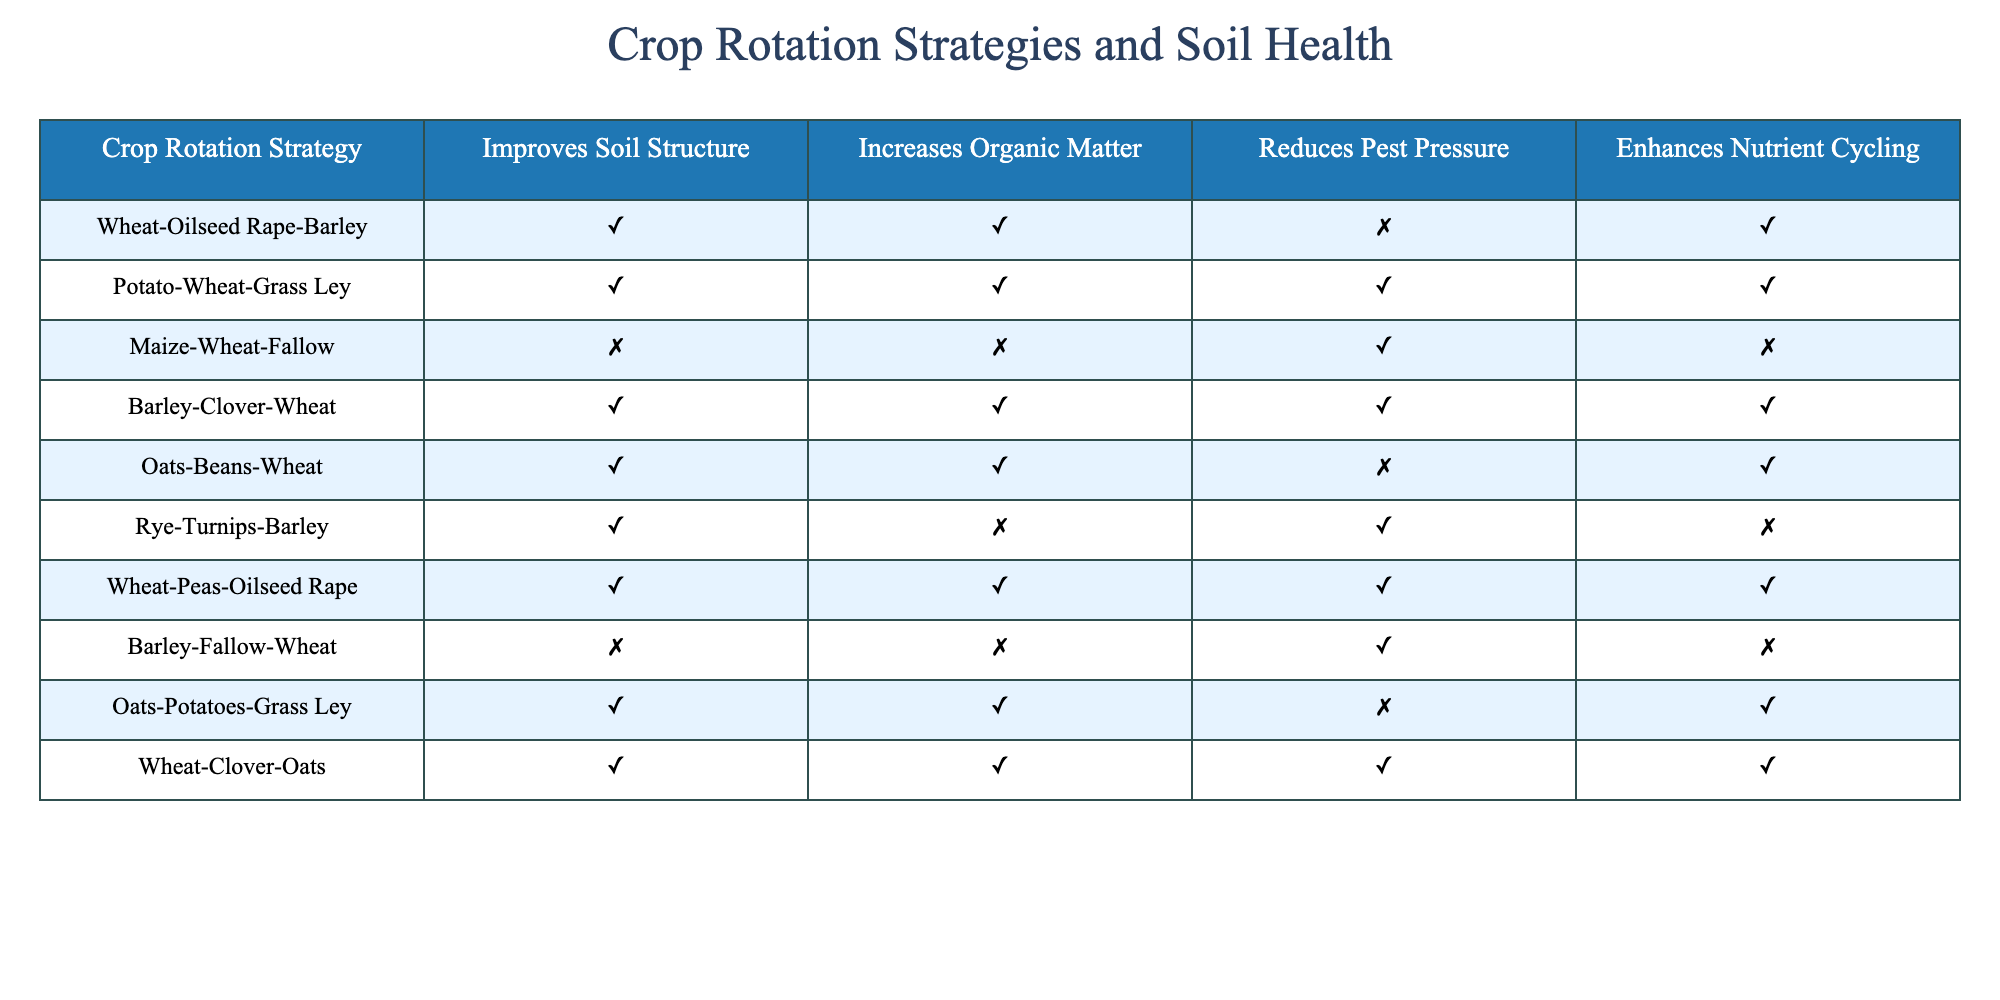What crop rotation strategy is most beneficial for enhancing nutrient cycling? The table shows that the strategies "Potato-Wheat-Grass Ley," "Barley-Clover-Wheat," "Wheat-Peas-Oilseed Rape," and "Wheat-Clover-Oats" all have a TRUE value for enhancing nutrient cycling. Among these, any of these could be considered the most beneficial, depending on other factors not presented in the table.
Answer: Multiple strategies Which crop rotation strategies improve soil structure? By looking at the column for "Improves Soil Structure," I can see that the strategies "Wheat-Oilseed Rape-Barley," "Potato-Wheat-Grass Ley," "Barley-Clover-Wheat," "Oats-Beans-Wheat," "Rye-Turnips-Barley," "Wheat-Peas-Oilseed Rape," "Oats-Potatoes-Grass Ley," and "Wheat-Clover-Oats" are marked TRUE. Therefore, there are eight strategies that improve soil structure.
Answer: Eight strategies Do any crop rotation strategies reduce pest pressure while enhancing nutrient cycling? To answer this, I look for strategies that have TRUE in both the "Reduces Pest Pressure" and "Enhances Nutrient Cycling" columns. The strategies "Potato-Wheat-Grass Ley," "Barley-Clover-Wheat," "Wheat-Peas-Oilseed Rape," and "Wheat-Clover-Oats" all check the box for nutrient cycling, but only "Potato-Wheat-Grass Ley," "Barley-Clover-Wheat," and "Wheat-Peas-Oilseed Rape" reduce pest pressure. Therefore, only these three strategies meet both criteria.
Answer: Yes, three strategies Which crop rotation strategy yields FALSE for both organic matter and improves soil structure? In the table, I look for a strategy that has FALSE in both the "Increases Organic Matter" and "Improves Soil Structure" columns. Upon reviewing the rows, "Maize-Wheat-Fallow" and "Barley-Fallow-Wheat" fulfill this condition. Therefore, there are two such strategies.
Answer: Two strategies How many crop rotation strategies do not enhance nutrient cycling at all? By reviewing the "Enhances Nutrient Cycling" column and noting how many strategies have a FALSE value, I see that the strategies "Maize-Wheat-Fallow" and "Barley-Fallow-Wheat" do not enhance nutrient cycling. Therefore, there are two strategies that do not enhance nutrient cycling.
Answer: Two strategies 